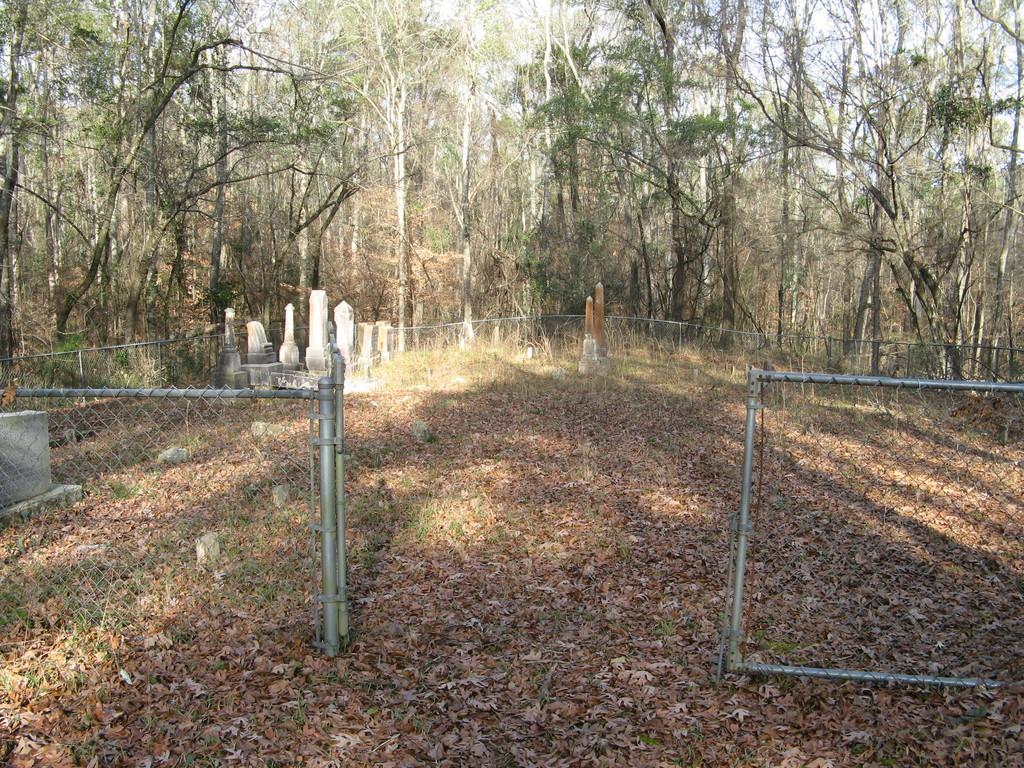Can you describe this image briefly? The picture is taken near a cemetery. In the foreground of the picture there are dry leaves, plants, stones, gravestones and fencing. In the background there are trees. It is sunny. 